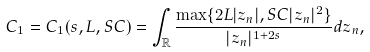Convert formula to latex. <formula><loc_0><loc_0><loc_500><loc_500>C _ { 1 } = C _ { 1 } ( s , L , S C ) = \int _ { \mathbb { R } } { \frac { \max \{ 2 L | z _ { n } | , S C | z _ { n } | ^ { 2 } \} } { | z _ { n } | ^ { 1 + 2 s } } d z _ { n } } ,</formula> 